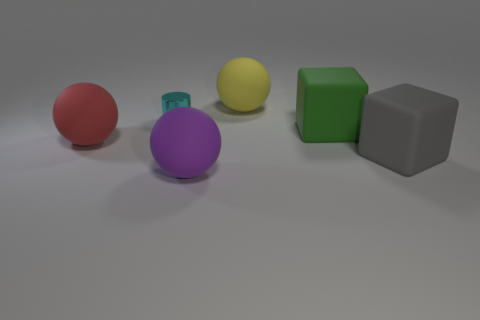Add 1 large yellow balls. How many objects exist? 7 Add 4 large purple rubber spheres. How many large purple rubber spheres exist? 5 Subtract 0 yellow cubes. How many objects are left? 6 Subtract all cylinders. How many objects are left? 5 Subtract all cyan matte spheres. Subtract all large balls. How many objects are left? 3 Add 4 cyan metal cylinders. How many cyan metal cylinders are left? 5 